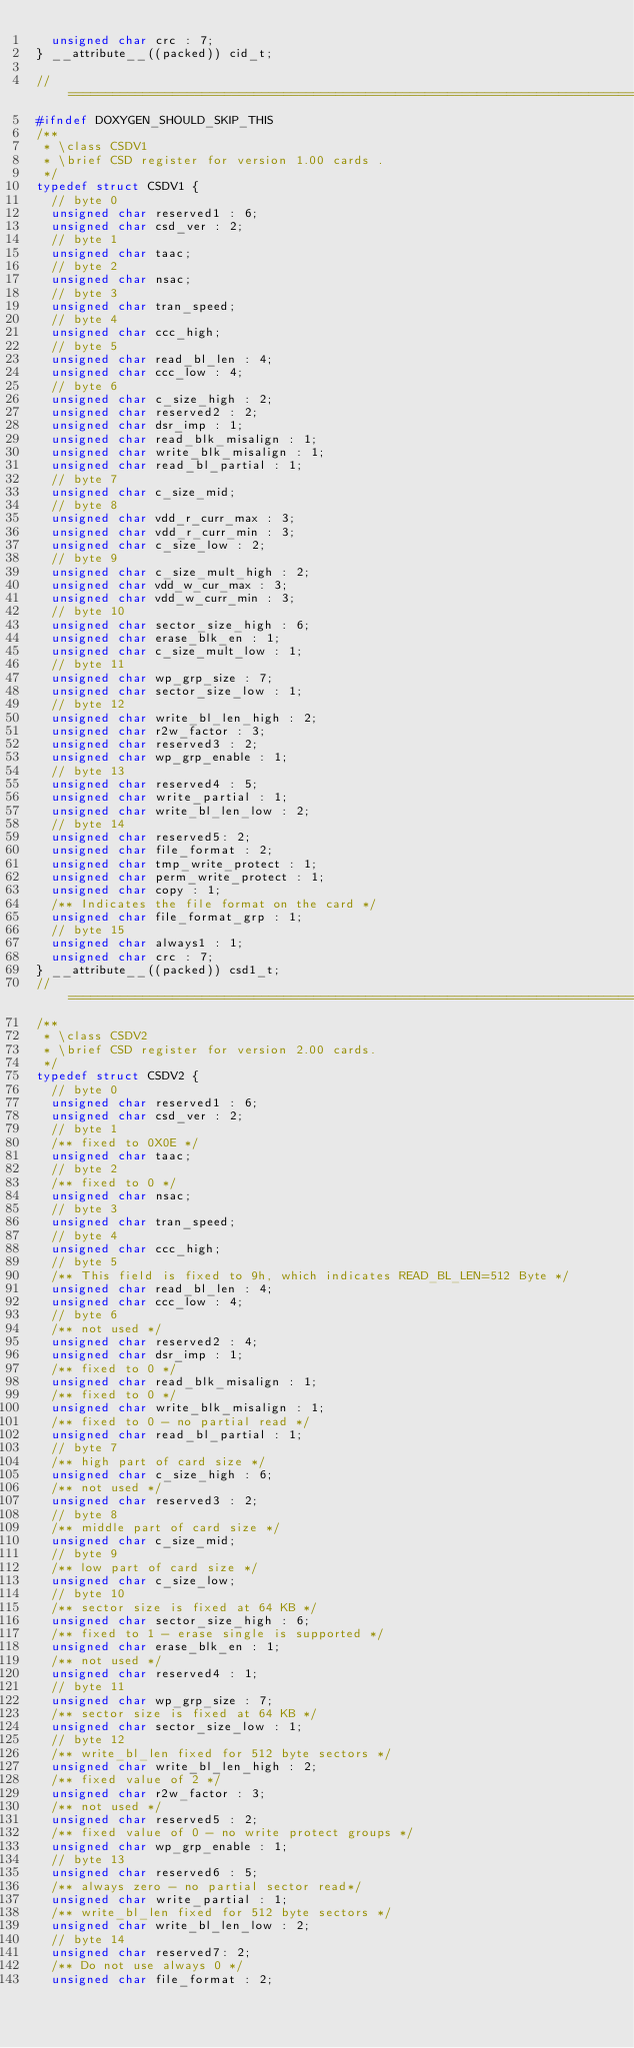Convert code to text. <code><loc_0><loc_0><loc_500><loc_500><_C_>  unsigned char crc : 7;
} __attribute__((packed)) cid_t;

//==============================================================================
#ifndef DOXYGEN_SHOULD_SKIP_THIS
/**
 * \class CSDV1
 * \brief CSD register for version 1.00 cards .
 */
typedef struct CSDV1 {
  // byte 0
  unsigned char reserved1 : 6;
  unsigned char csd_ver : 2;
  // byte 1
  unsigned char taac;
  // byte 2
  unsigned char nsac;
  // byte 3
  unsigned char tran_speed;
  // byte 4
  unsigned char ccc_high;
  // byte 5
  unsigned char read_bl_len : 4;
  unsigned char ccc_low : 4;
  // byte 6
  unsigned char c_size_high : 2;
  unsigned char reserved2 : 2;
  unsigned char dsr_imp : 1;
  unsigned char read_blk_misalign : 1;
  unsigned char write_blk_misalign : 1;
  unsigned char read_bl_partial : 1;
  // byte 7
  unsigned char c_size_mid;
  // byte 8
  unsigned char vdd_r_curr_max : 3;
  unsigned char vdd_r_curr_min : 3;
  unsigned char c_size_low : 2;
  // byte 9
  unsigned char c_size_mult_high : 2;
  unsigned char vdd_w_cur_max : 3;
  unsigned char vdd_w_curr_min : 3;
  // byte 10
  unsigned char sector_size_high : 6;
  unsigned char erase_blk_en : 1;
  unsigned char c_size_mult_low : 1;
  // byte 11
  unsigned char wp_grp_size : 7;
  unsigned char sector_size_low : 1;
  // byte 12
  unsigned char write_bl_len_high : 2;
  unsigned char r2w_factor : 3;
  unsigned char reserved3 : 2;
  unsigned char wp_grp_enable : 1;
  // byte 13
  unsigned char reserved4 : 5;
  unsigned char write_partial : 1;
  unsigned char write_bl_len_low : 2;
  // byte 14
  unsigned char reserved5: 2;
  unsigned char file_format : 2;
  unsigned char tmp_write_protect : 1;
  unsigned char perm_write_protect : 1;
  unsigned char copy : 1;
  /** Indicates the file format on the card */
  unsigned char file_format_grp : 1;
  // byte 15
  unsigned char always1 : 1;
  unsigned char crc : 7;
} __attribute__((packed)) csd1_t;
//==============================================================================
/**
 * \class CSDV2
 * \brief CSD register for version 2.00 cards.
 */
typedef struct CSDV2 {
  // byte 0
  unsigned char reserved1 : 6;
  unsigned char csd_ver : 2;
  // byte 1
  /** fixed to 0X0E */
  unsigned char taac;
  // byte 2
  /** fixed to 0 */
  unsigned char nsac;
  // byte 3
  unsigned char tran_speed;
  // byte 4
  unsigned char ccc_high;
  // byte 5
  /** This field is fixed to 9h, which indicates READ_BL_LEN=512 Byte */
  unsigned char read_bl_len : 4;
  unsigned char ccc_low : 4;
  // byte 6
  /** not used */
  unsigned char reserved2 : 4;
  unsigned char dsr_imp : 1;
  /** fixed to 0 */
  unsigned char read_blk_misalign : 1;
  /** fixed to 0 */
  unsigned char write_blk_misalign : 1;
  /** fixed to 0 - no partial read */
  unsigned char read_bl_partial : 1;
  // byte 7
  /** high part of card size */
  unsigned char c_size_high : 6;
  /** not used */
  unsigned char reserved3 : 2;
  // byte 8
  /** middle part of card size */
  unsigned char c_size_mid;
  // byte 9
  /** low part of card size */
  unsigned char c_size_low;
  // byte 10
  /** sector size is fixed at 64 KB */
  unsigned char sector_size_high : 6;
  /** fixed to 1 - erase single is supported */
  unsigned char erase_blk_en : 1;
  /** not used */
  unsigned char reserved4 : 1;
  // byte 11
  unsigned char wp_grp_size : 7;
  /** sector size is fixed at 64 KB */
  unsigned char sector_size_low : 1;
  // byte 12
  /** write_bl_len fixed for 512 byte sectors */
  unsigned char write_bl_len_high : 2;
  /** fixed value of 2 */
  unsigned char r2w_factor : 3;
  /** not used */
  unsigned char reserved5 : 2;
  /** fixed value of 0 - no write protect groups */
  unsigned char wp_grp_enable : 1;
  // byte 13
  unsigned char reserved6 : 5;
  /** always zero - no partial sector read*/
  unsigned char write_partial : 1;
  /** write_bl_len fixed for 512 byte sectors */
  unsigned char write_bl_len_low : 2;
  // byte 14
  unsigned char reserved7: 2;
  /** Do not use always 0 */
  unsigned char file_format : 2;</code> 